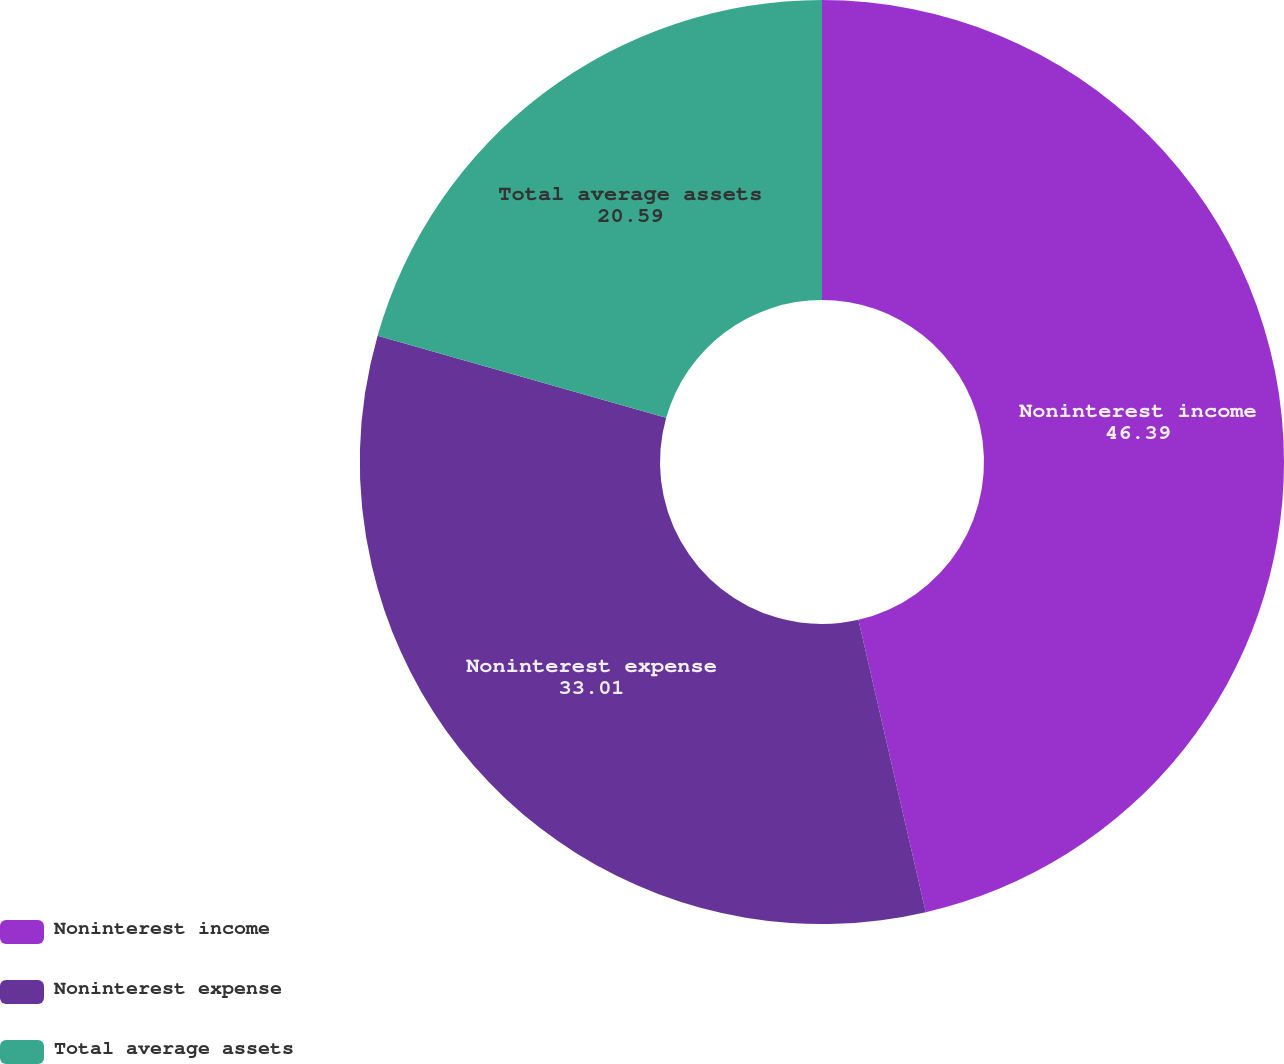<chart> <loc_0><loc_0><loc_500><loc_500><pie_chart><fcel>Noninterest income<fcel>Noninterest expense<fcel>Total average assets<nl><fcel>46.39%<fcel>33.01%<fcel>20.59%<nl></chart> 